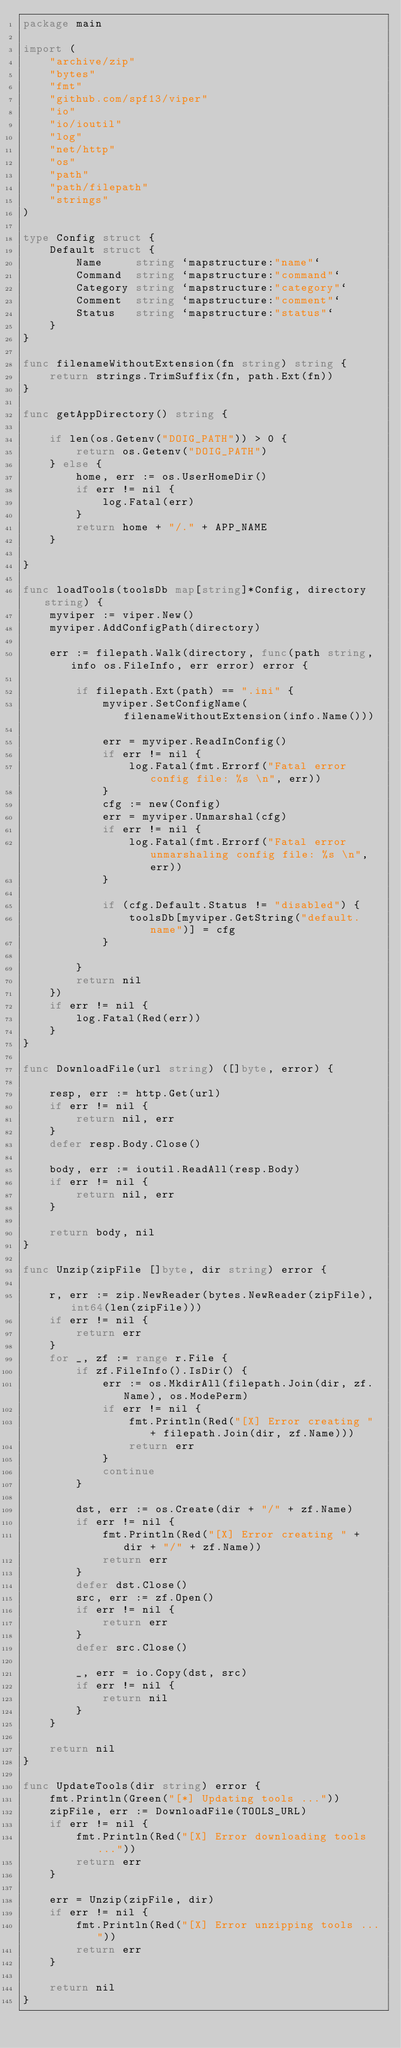Convert code to text. <code><loc_0><loc_0><loc_500><loc_500><_Go_>package main

import (
	"archive/zip"
	"bytes"
	"fmt"
	"github.com/spf13/viper"
	"io"
	"io/ioutil"
	"log"
	"net/http"
	"os"
	"path"
	"path/filepath"
	"strings"
)

type Config struct {
	Default struct {
		Name     string `mapstructure:"name"`
		Command  string `mapstructure:"command"`
		Category string `mapstructure:"category"`
		Comment  string `mapstructure:"comment"`
		Status   string `mapstructure:"status"`
	}
}

func filenameWithoutExtension(fn string) string {
	return strings.TrimSuffix(fn, path.Ext(fn))
}

func getAppDirectory() string {

	if len(os.Getenv("DOIG_PATH")) > 0 {
		return os.Getenv("DOIG_PATH")
	} else {
		home, err := os.UserHomeDir()
		if err != nil {
			log.Fatal(err)
		}
		return home + "/." + APP_NAME
	}

}

func loadTools(toolsDb map[string]*Config, directory string) {
	myviper := viper.New()
	myviper.AddConfigPath(directory)

	err := filepath.Walk(directory, func(path string, info os.FileInfo, err error) error {

		if filepath.Ext(path) == ".ini" {
			myviper.SetConfigName(filenameWithoutExtension(info.Name()))

			err = myviper.ReadInConfig()
			if err != nil {
				log.Fatal(fmt.Errorf("Fatal error config file: %s \n", err))
			}
			cfg := new(Config)
			err = myviper.Unmarshal(cfg)
			if err != nil {
				log.Fatal(fmt.Errorf("Fatal error unmarshaling config file: %s \n", err))
			}

			if (cfg.Default.Status != "disabled") {
				toolsDb[myviper.GetString("default.name")] = cfg
			}

		}
		return nil
	})
	if err != nil {
		log.Fatal(Red(err))
	}
}

func DownloadFile(url string) ([]byte, error) {

	resp, err := http.Get(url)
	if err != nil {
		return nil, err
	}
	defer resp.Body.Close()

	body, err := ioutil.ReadAll(resp.Body)
	if err != nil {
		return nil, err
	}

	return body, nil
}

func Unzip(zipFile []byte, dir string) error {

	r, err := zip.NewReader(bytes.NewReader(zipFile), int64(len(zipFile)))
	if err != nil {
		return err
	}
	for _, zf := range r.File {
		if zf.FileInfo().IsDir() {
			err := os.MkdirAll(filepath.Join(dir, zf.Name), os.ModePerm)
			if err != nil {
				fmt.Println(Red("[X] Error creating " + filepath.Join(dir, zf.Name)))
				return err
			}
			continue
		}

		dst, err := os.Create(dir + "/" + zf.Name)
		if err != nil {
			fmt.Println(Red("[X] Error creating " + dir + "/" + zf.Name))
			return err
		}
		defer dst.Close()
		src, err := zf.Open()
		if err != nil {
			return err
		}
		defer src.Close()

		_, err = io.Copy(dst, src)
		if err != nil {
			return nil
		}
	}

	return nil
}

func UpdateTools(dir string) error {
	fmt.Println(Green("[*] Updating tools ..."))
	zipFile, err := DownloadFile(TOOLS_URL)
	if err != nil {
		fmt.Println(Red("[X] Error downloading tools ..."))
		return err
	}

	err = Unzip(zipFile, dir)
	if err != nil {
		fmt.Println(Red("[X] Error unzipping tools ..."))
		return err
	}

	return nil
}
</code> 